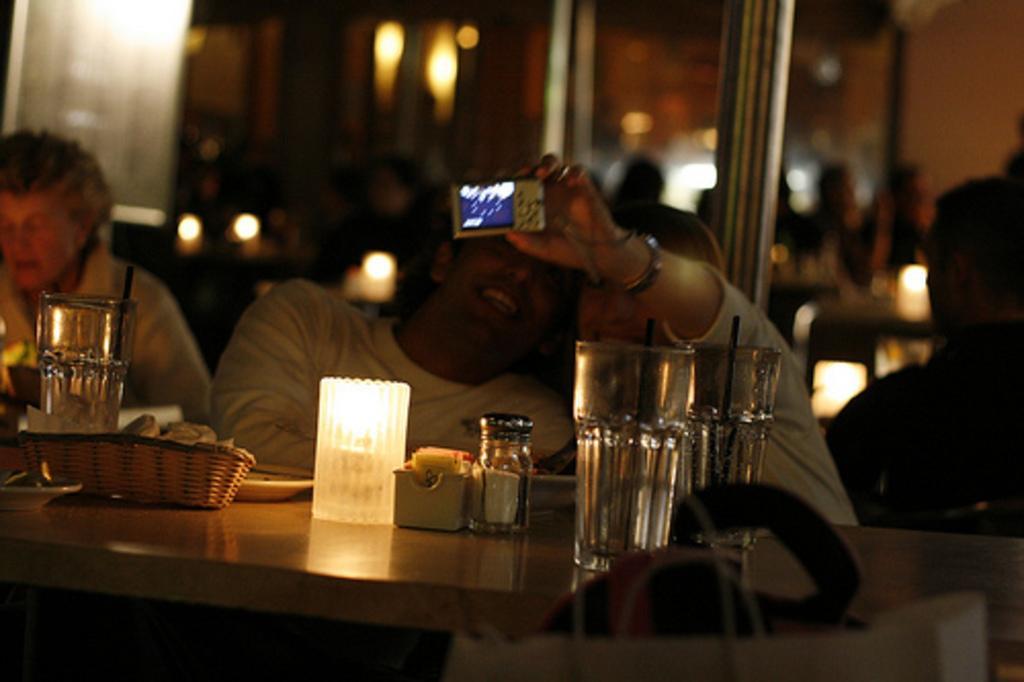How would you summarize this image in a sentence or two? In the center of the image there is a table on which there are glasses,basket and other objects. In the background of the image there are people. There is a lady holding a camera. At the bottom of the image there is a white color bag. 